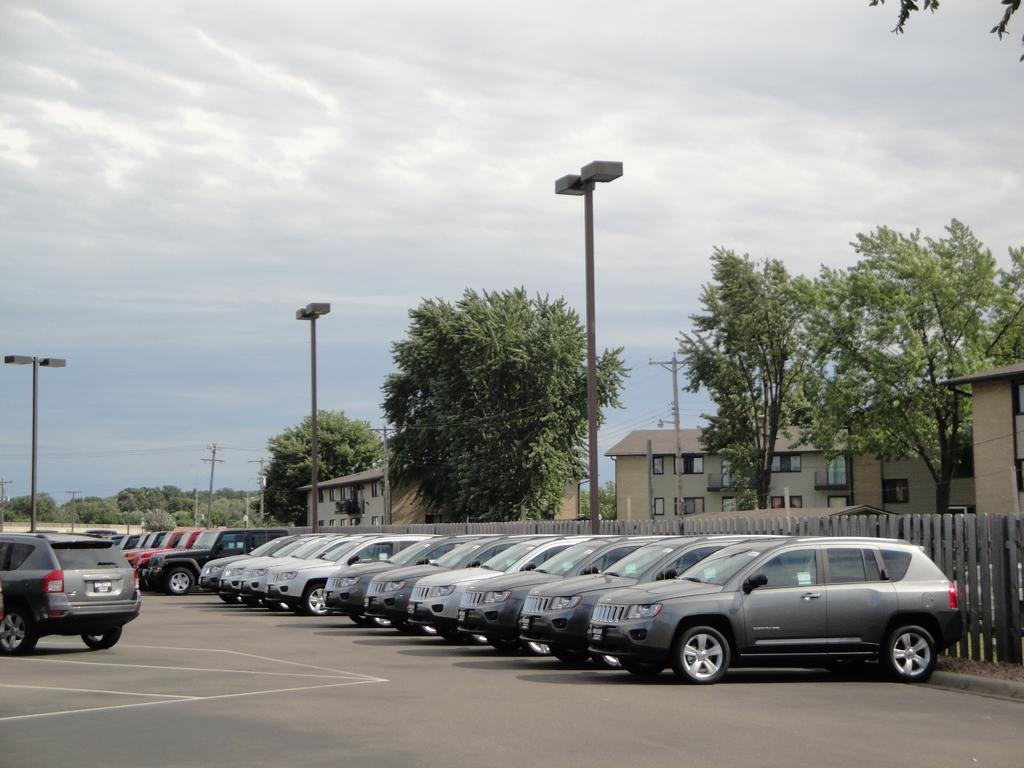What type of vehicles can be seen on the road in the image? There are cars on the road in the image. What structures are present near the road? There are lights on poles and a fence in the image. What can be seen in the background of the image? There are buildings, trees, current poles, wires, and the sky visible in the background. Where is the pencil hole in the image? There is no pencil hole present in the image. What type of plastic objects can be seen in the image? There are no plastic objects visible in the image. 